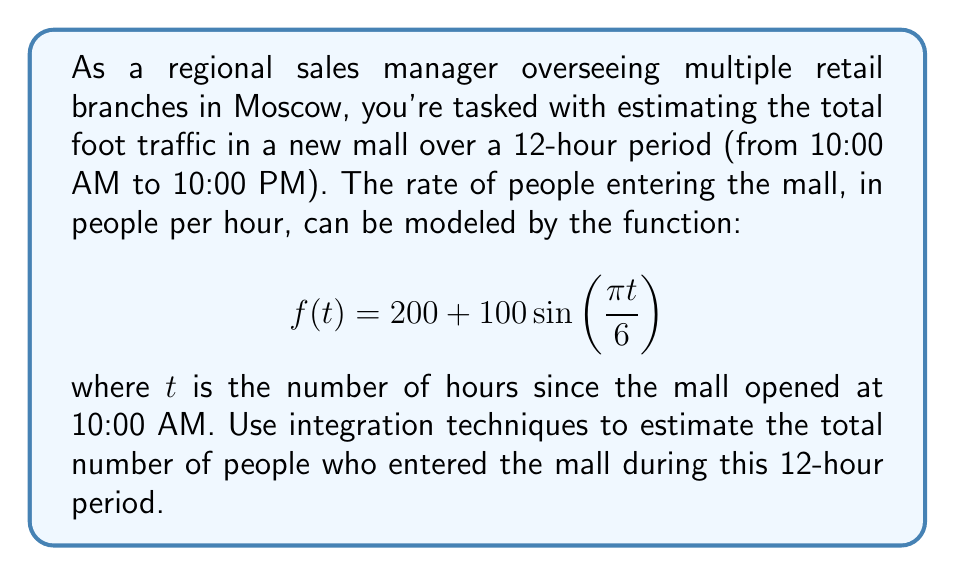Give your solution to this math problem. To solve this problem, we need to integrate the given function over the 12-hour period. Here's a step-by-step approach:

1) The function $f(t)$ represents the rate at which people enter the mall at any given time $t$. To find the total number of people, we need to integrate this function over the entire time period.

2) We'll use the definite integral from $t=0$ to $t=12$:

   $$\int_0^{12} f(t) dt = \int_0^{12} \left(200 + 100\sin\left(\frac{\pi t}{6}\right)\right) dt$$

3) Let's break this into two integrals:

   $$\int_0^{12} 200 dt + \int_0^{12} 100\sin\left(\frac{\pi t}{6}\right) dt$$

4) The first integral is straightforward:

   $$\int_0^{12} 200 dt = 200t \bigg|_0^{12} = 200(12) - 200(0) = 2400$$

5) For the second integral, we'll use the substitution method. Let $u = \frac{\pi t}{6}$, then $du = \frac{\pi}{6} dt$ or $dt = \frac{6}{\pi} du$:

   $$100 \int_0^{2\pi} \sin(u) \cdot \frac{6}{\pi} du = \frac{600}{\pi} \int_0^{2\pi} \sin(u) du$$

6) We know that $\int \sin(u) du = -\cos(u) + C$, so:

   $$\frac{600}{\pi} \left[-\cos(u)\right]_0^{2\pi} = \frac{600}{\pi} \left[-\cos(2\pi) + \cos(0)\right] = \frac{600}{\pi} (0) = 0$$

7) Adding the results from steps 4 and 6:

   $$2400 + 0 = 2400$$

Therefore, an estimated 2,400 people entered the mall during the 12-hour period.
Answer: 2,400 people 